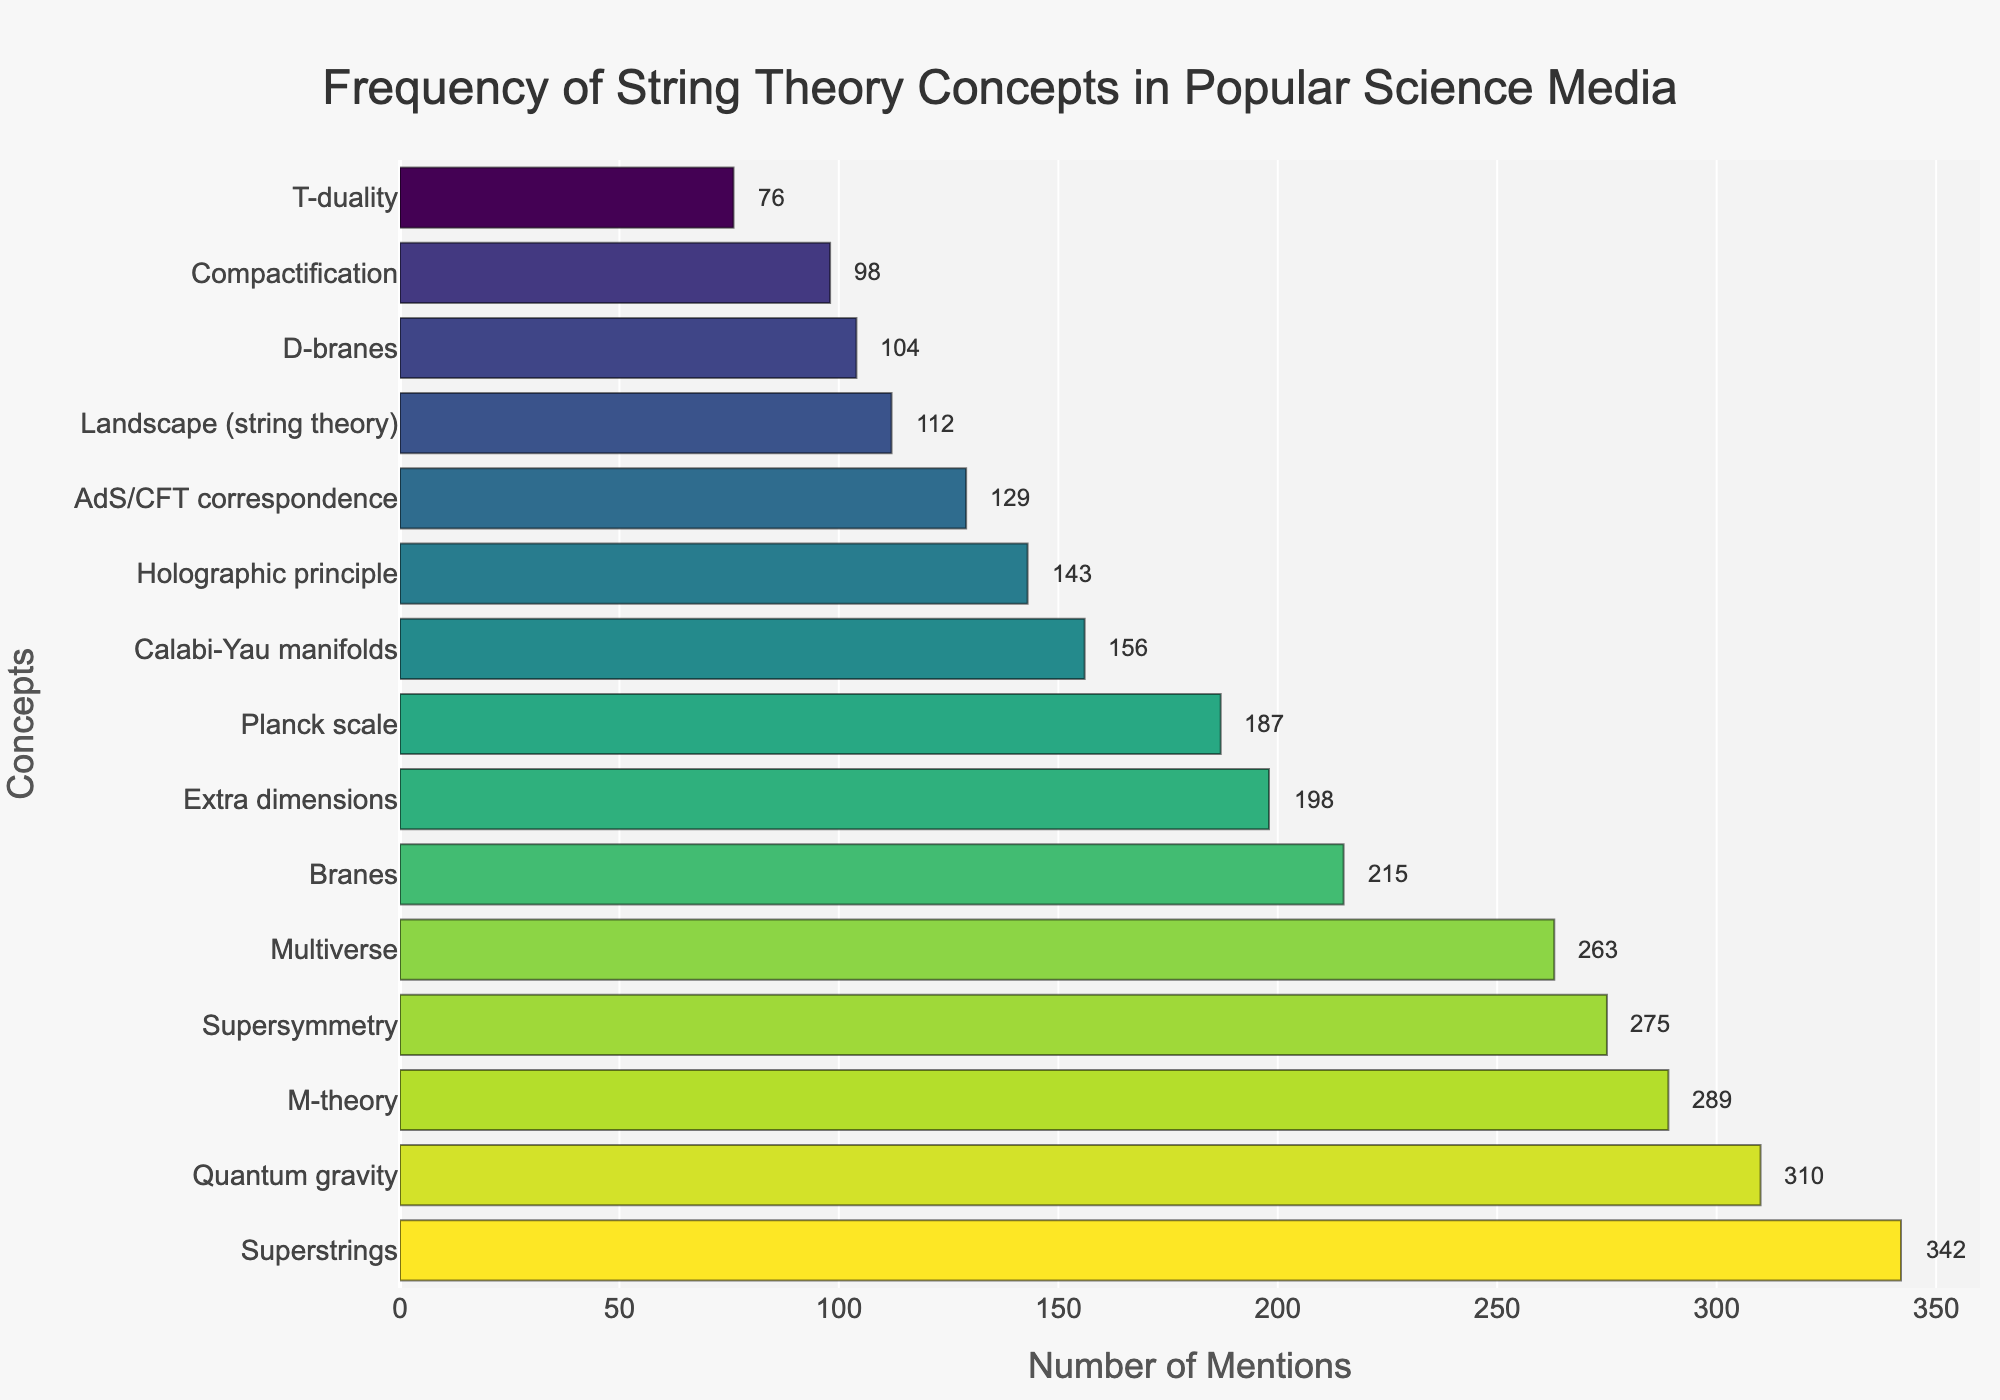Which string theory concept is mentioned the most? The concept with the longest bar and highest mention count at the top of the sorted list is "Superstrings" with 342 mentions.
Answer: Superstrings How many more mentions does "M-theory" have compared to "Branes"? "M-theory" has 289 mentions and "Branes" has 215 mentions. Subtract 215 from 289 to get the difference: 289 - 215 = 74.
Answer: 74 What is the combined number of mentions for "Calabi-Yau manifolds" and "Holographic principle"? Add the mentions for "Calabi-Yau manifolds" (156) and "Holographic principle" (143): 156 + 143 = 299.
Answer: 299 Which concept is the fifth most mentioned in the figure? The fifth bar from the top represents "Supersymmetry" with 275 mentions.
Answer: Supersymmetry Is "Quantum gravity" mentioned more often than "Multiverse"? "Quantum gravity" has 310 mentions, while "Multiverse" has 263 mentions. Since 310 is greater than 263, "Quantum gravity" is mentioned more often.
Answer: Yes What is the average number of mentions for the top three concepts? The top three concepts are "Superstrings" (342), "Quantum gravity" (310), and "M-theory" (289). Find the sum and then divide by three: (342 + 310 + 289) / 3 = 941 / 3 ≈ 313.67.
Answer: 313.67 Which concept is mentioned the least, and how many mentions does it have? The shortest bar represents "T-duality" with 76 mentions.
Answer: T-duality, 76 Visual Question: What visual attribute differentiates the bars aside from their length? The bars are differentiated by their color, which varies across a "Viridis" colorscale from lighter to darker shades based on the logarithm of their mentions.
Answer: Color gradient Compare the mentions of "Landscape (string theory)" to the mention of "D-branes". Which has fewer mentions and by how much? "Landscape (string theory)" has 112 mentions and "D-branes" has 104 mentions. Subtract 104 from 112 to find the difference: 112 - 104 = 8.
Answer: D-branes, 8 